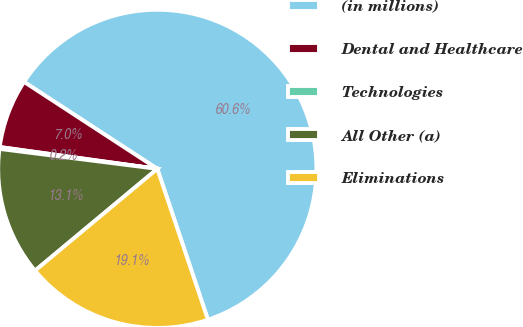<chart> <loc_0><loc_0><loc_500><loc_500><pie_chart><fcel>(in millions)<fcel>Dental and Healthcare<fcel>Technologies<fcel>All Other (a)<fcel>Eliminations<nl><fcel>60.64%<fcel>7.01%<fcel>0.19%<fcel>13.05%<fcel>19.1%<nl></chart> 